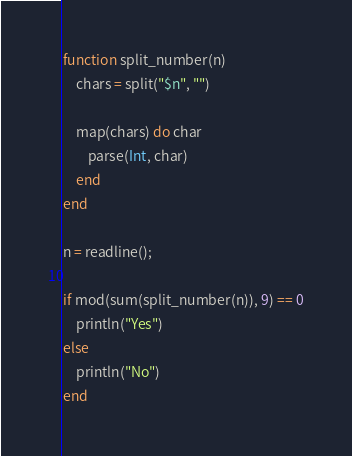<code> <loc_0><loc_0><loc_500><loc_500><_Julia_>function split_number(n)
    chars = split("$n", "")

    map(chars) do char
        parse(Int, char)
    end
end

n = readline();

if mod(sum(split_number(n)), 9) == 0
    println("Yes")
else
    println("No")
end</code> 